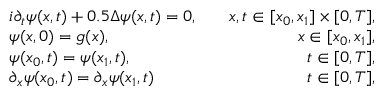<formula> <loc_0><loc_0><loc_500><loc_500>\begin{array} { r l r } & { i \partial _ { t } \psi ( x , t ) + 0 . 5 \Delta \psi ( x , t ) = 0 , } & { \quad x , t \in [ x _ { 0 } , x _ { 1 } ] \times [ 0 , T ] , } \\ & { \psi ( x , 0 ) = g ( x ) , } & { \quad x \in [ x _ { 0 } , x _ { 1 } ] , } \\ & { \psi ( x _ { 0 } , t ) = \psi ( x _ { 1 } , t ) , } & { \quad t \in [ 0 , T ] , } \\ & { \partial _ { x } \psi ( x _ { 0 } , t ) = \partial _ { x } \psi ( x _ { 1 } , t ) } & { \quad t \in [ 0 , T ] , } \end{array}</formula> 